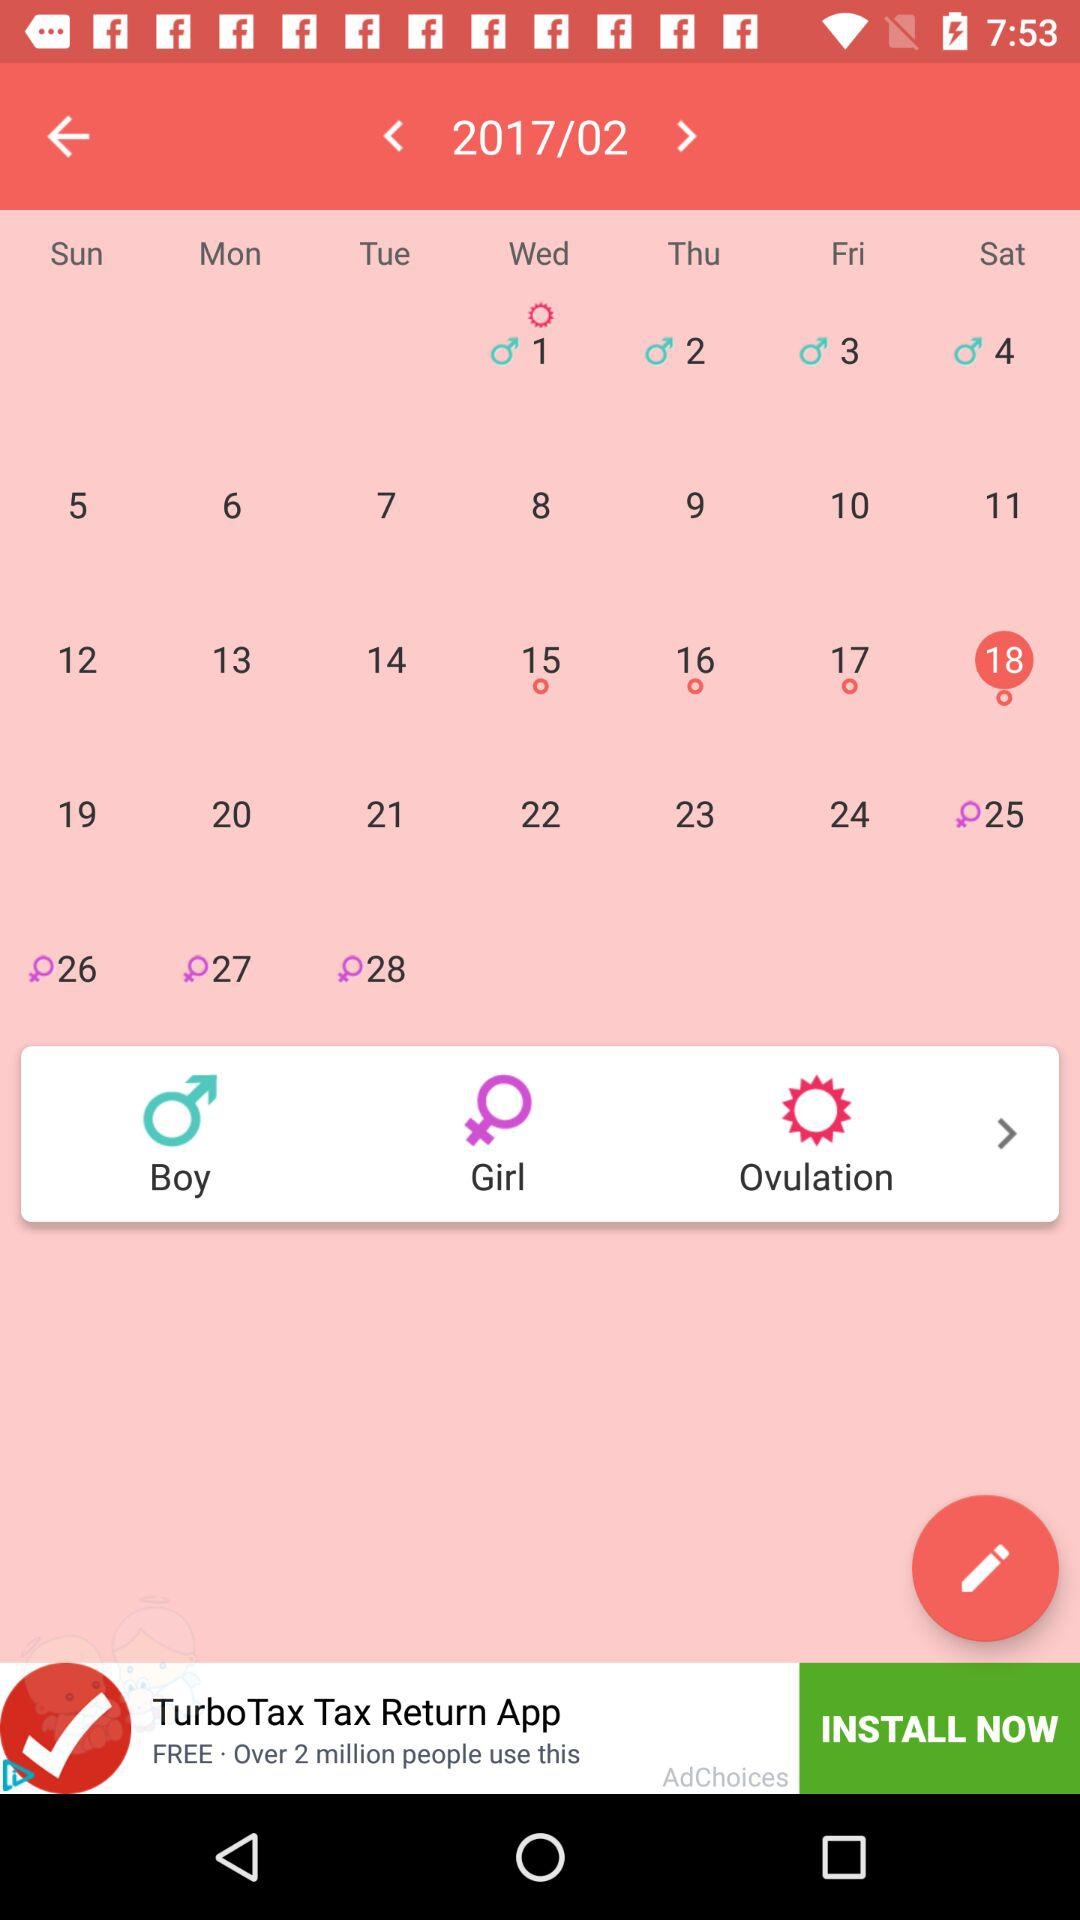What is the calendar year? The calendar year is 2017. 